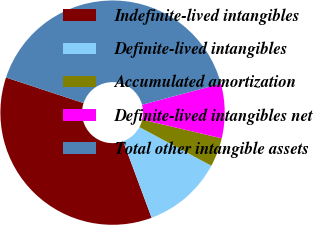<chart> <loc_0><loc_0><loc_500><loc_500><pie_chart><fcel>Indefinite-lived intangibles<fcel>Definite-lived intangibles<fcel>Accumulated amortization<fcel>Definite-lived intangibles net<fcel>Total other intangible assets<nl><fcel>35.74%<fcel>11.49%<fcel>4.17%<fcel>7.83%<fcel>40.78%<nl></chart> 